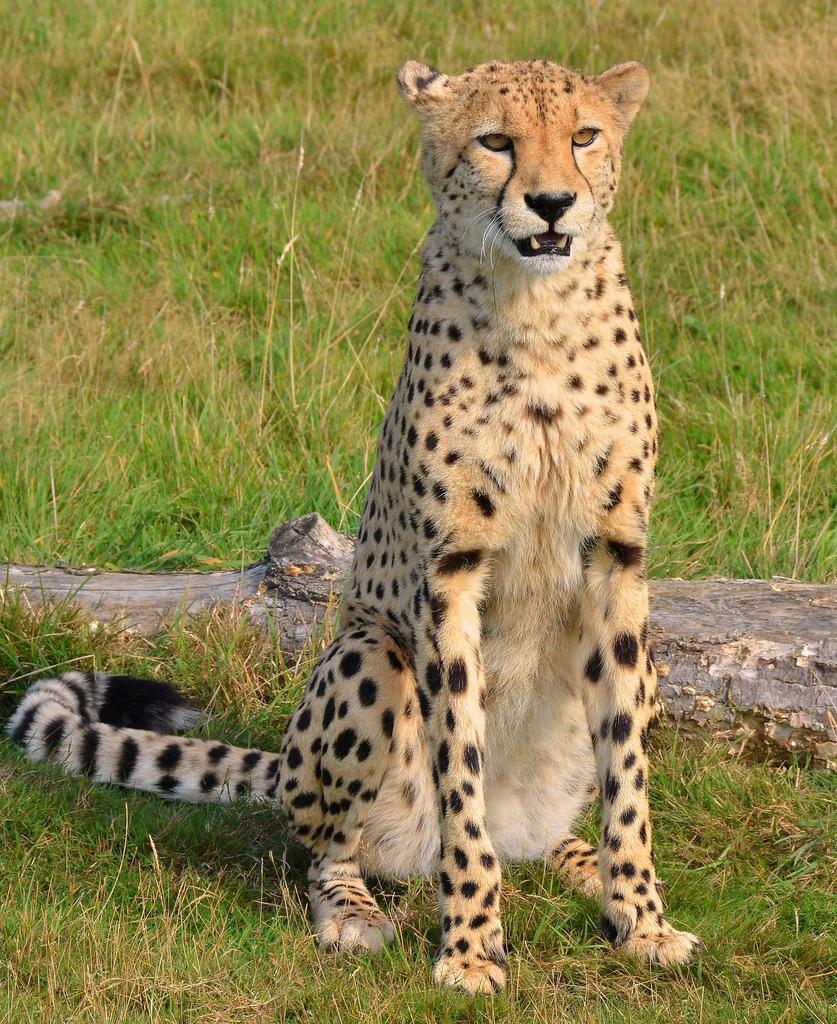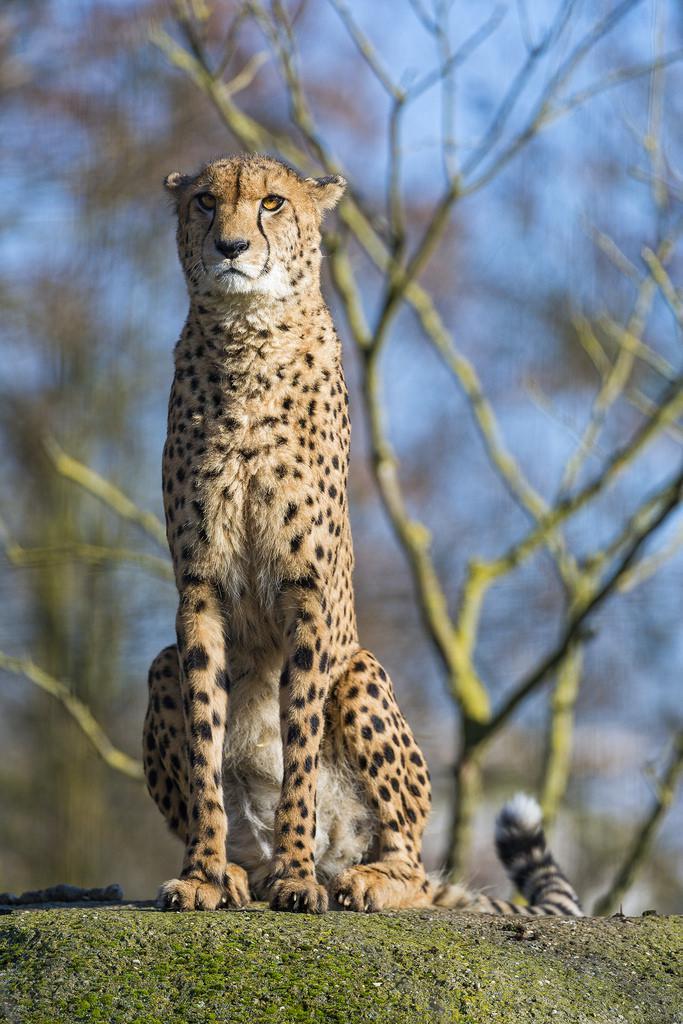The first image is the image on the left, the second image is the image on the right. For the images shown, is this caption "Each image shows a single sitting adult cheetah with its head upright and its face turned mostly forward." true? Answer yes or no. Yes. 